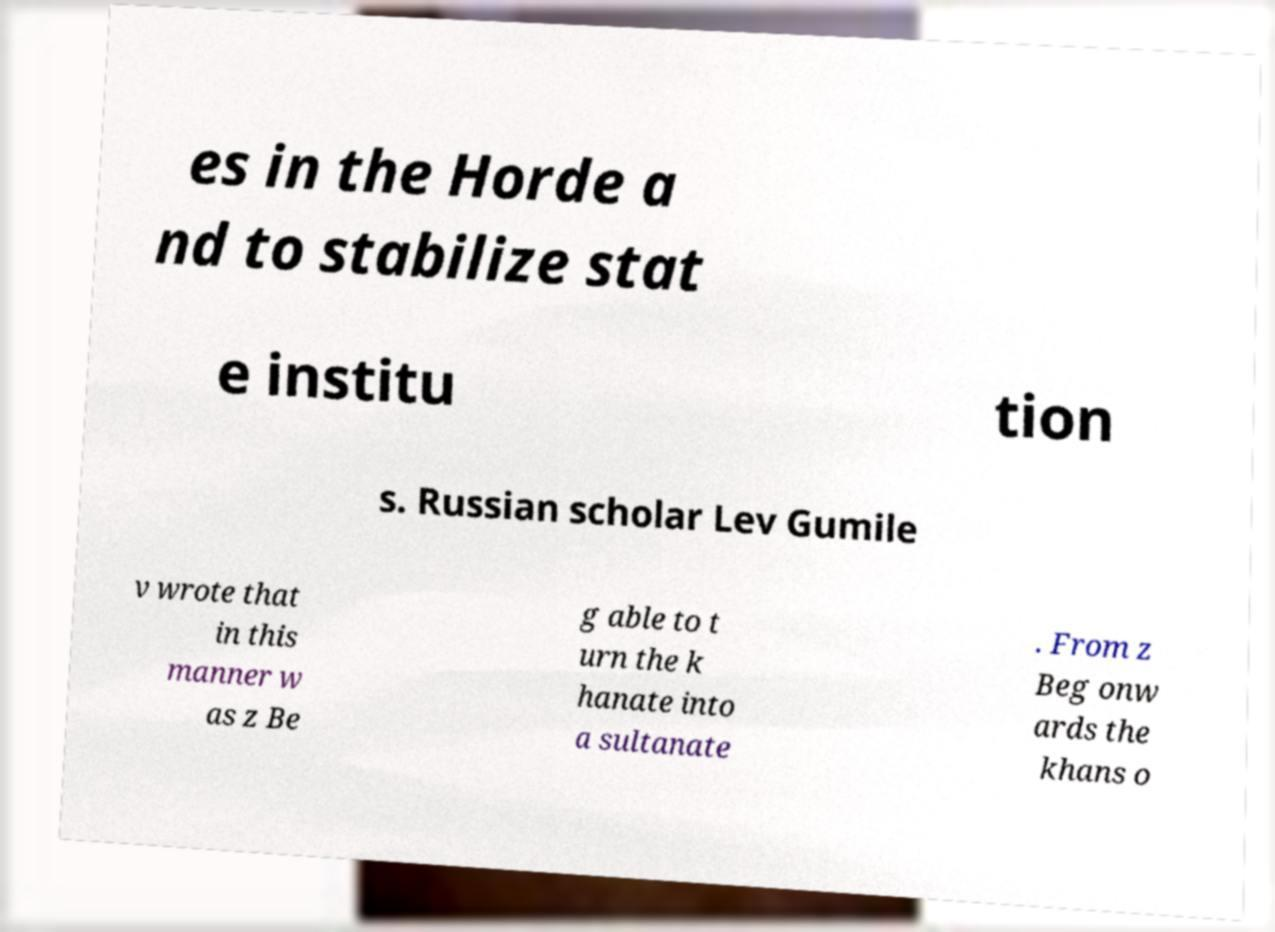Could you extract and type out the text from this image? es in the Horde a nd to stabilize stat e institu tion s. Russian scholar Lev Gumile v wrote that in this manner w as z Be g able to t urn the k hanate into a sultanate . From z Beg onw ards the khans o 